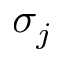Convert formula to latex. <formula><loc_0><loc_0><loc_500><loc_500>\sigma _ { j }</formula> 